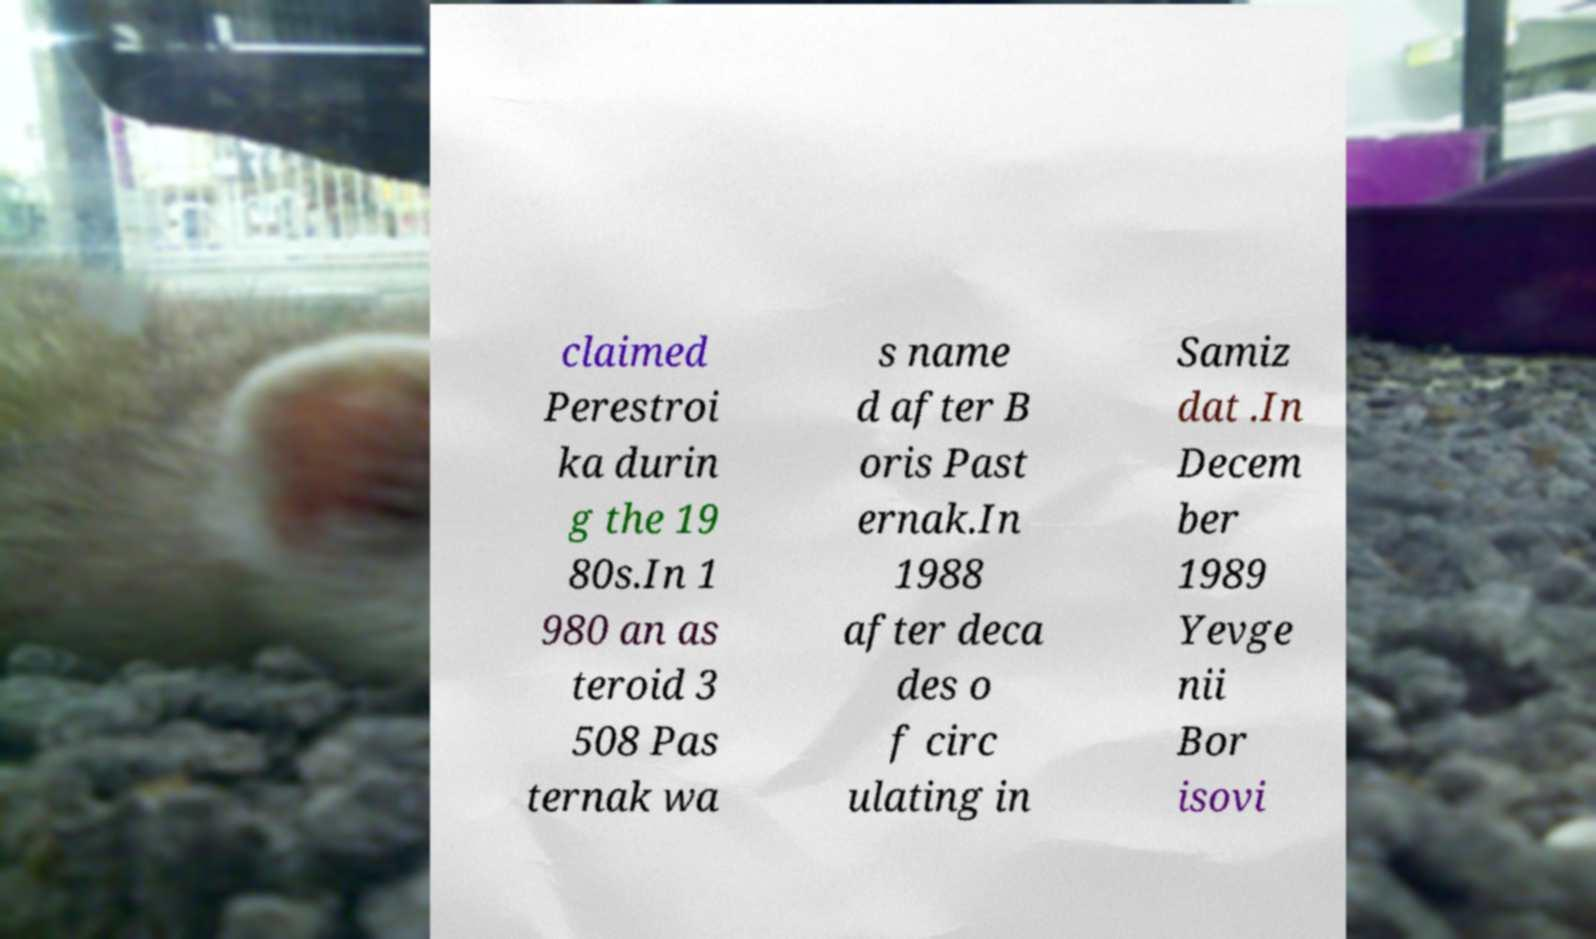Could you assist in decoding the text presented in this image and type it out clearly? claimed Perestroi ka durin g the 19 80s.In 1 980 an as teroid 3 508 Pas ternak wa s name d after B oris Past ernak.In 1988 after deca des o f circ ulating in Samiz dat .In Decem ber 1989 Yevge nii Bor isovi 